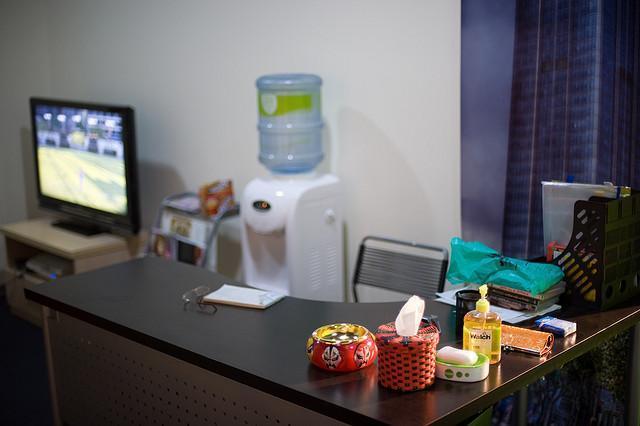How many zebras are there?
Give a very brief answer. 0. 